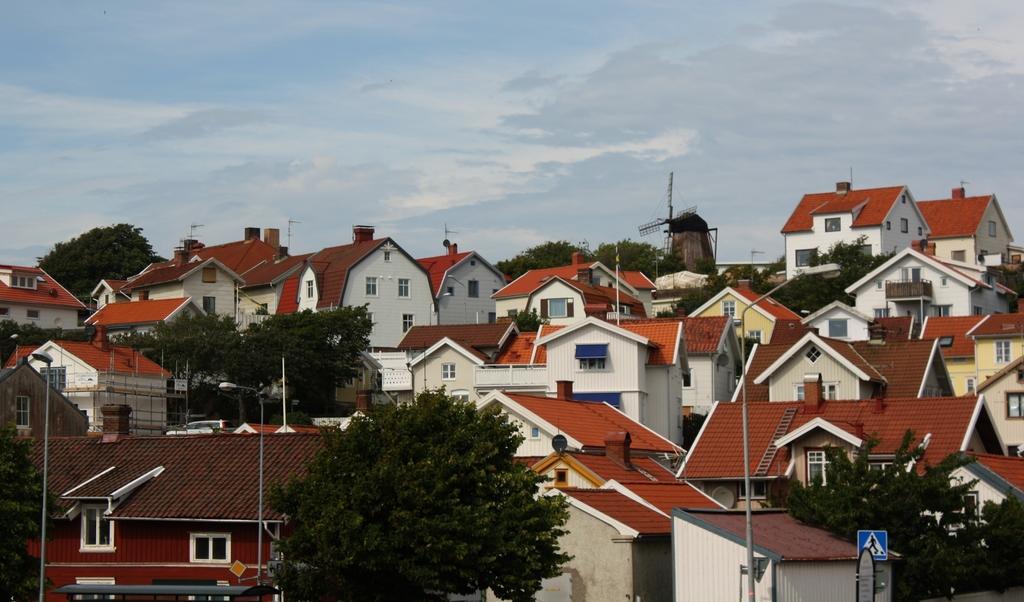Please provide a concise description of this image. In this picture we can see trees, poles, signboard, ladder, buildings with windows, some objects and in the background we can see the sky. 